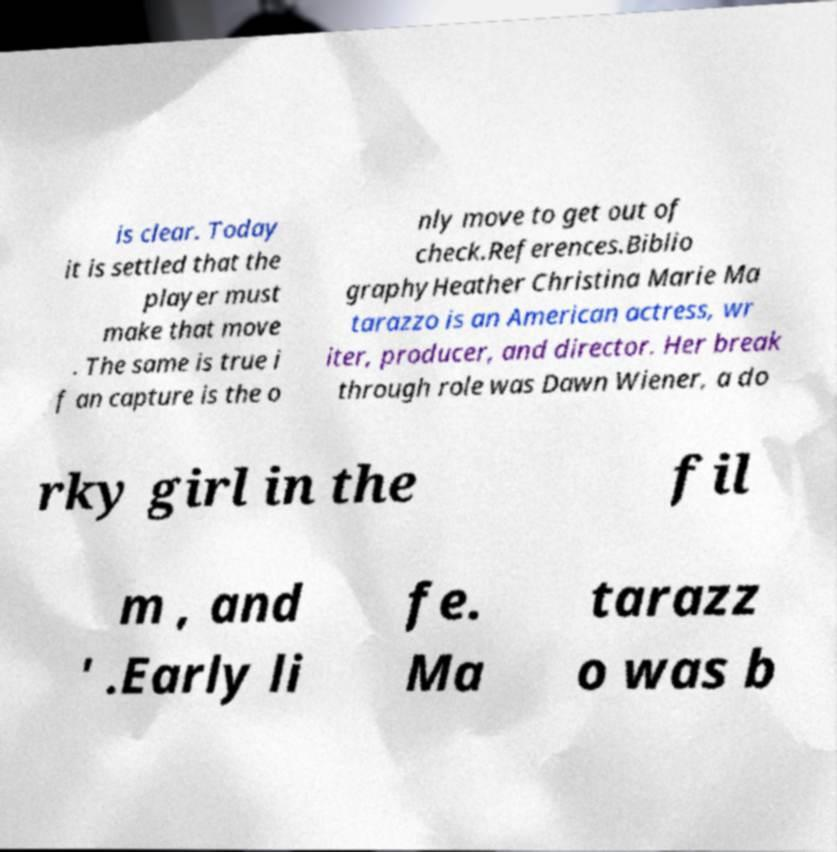For documentation purposes, I need the text within this image transcribed. Could you provide that? is clear. Today it is settled that the player must make that move . The same is true i f an capture is the o nly move to get out of check.References.Biblio graphyHeather Christina Marie Ma tarazzo is an American actress, wr iter, producer, and director. Her break through role was Dawn Wiener, a do rky girl in the fil m , and ' .Early li fe. Ma tarazz o was b 